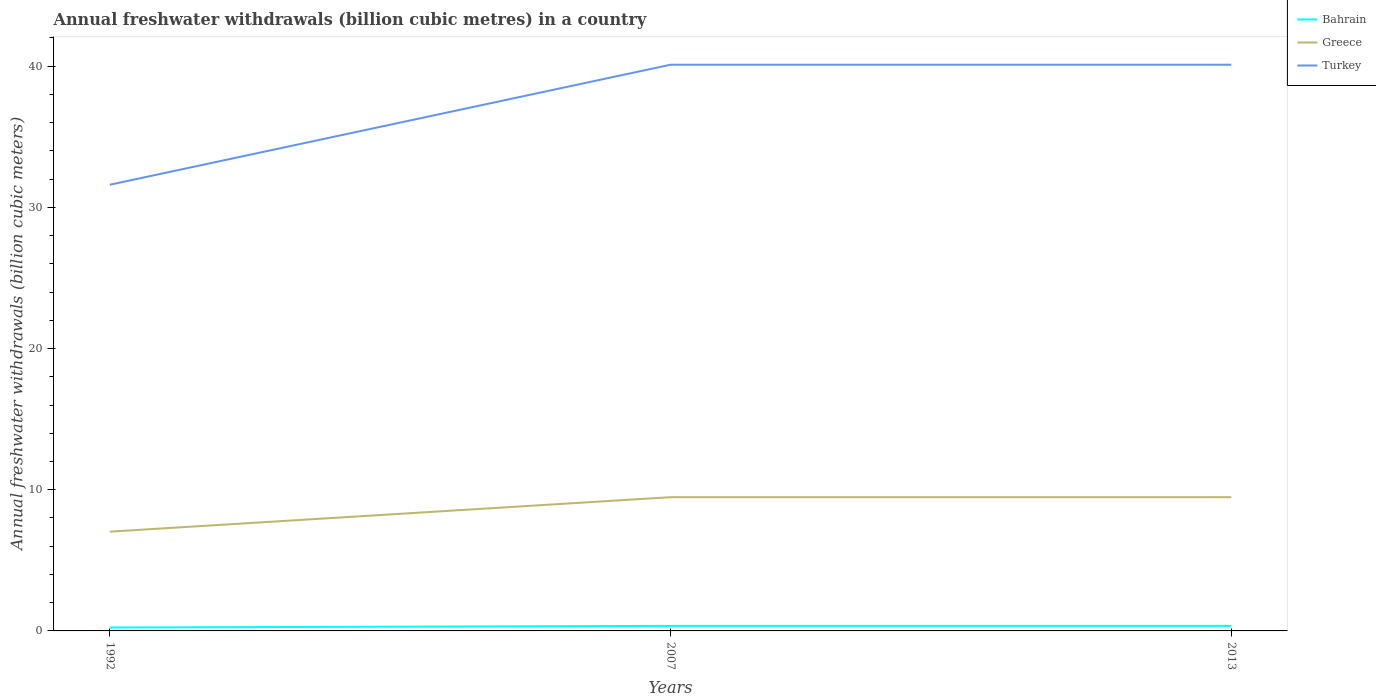Does the line corresponding to Turkey intersect with the line corresponding to Bahrain?
Your response must be concise. No. Across all years, what is the maximum annual freshwater withdrawals in Turkey?
Your answer should be compact. 31.6. In which year was the annual freshwater withdrawals in Turkey maximum?
Give a very brief answer. 1992. What is the total annual freshwater withdrawals in Turkey in the graph?
Offer a very short reply. -8.5. What is the difference between the highest and the second highest annual freshwater withdrawals in Greece?
Keep it short and to the point. 2.44. What is the difference between the highest and the lowest annual freshwater withdrawals in Bahrain?
Provide a succinct answer. 2. Is the annual freshwater withdrawals in Greece strictly greater than the annual freshwater withdrawals in Bahrain over the years?
Your answer should be compact. No. How many years are there in the graph?
Keep it short and to the point. 3. How many legend labels are there?
Offer a very short reply. 3. How are the legend labels stacked?
Provide a succinct answer. Vertical. What is the title of the graph?
Give a very brief answer. Annual freshwater withdrawals (billion cubic metres) in a country. Does "Montenegro" appear as one of the legend labels in the graph?
Keep it short and to the point. No. What is the label or title of the Y-axis?
Provide a succinct answer. Annual freshwater withdrawals (billion cubic meters). What is the Annual freshwater withdrawals (billion cubic meters) of Bahrain in 1992?
Your answer should be compact. 0.24. What is the Annual freshwater withdrawals (billion cubic meters) of Greece in 1992?
Make the answer very short. 7.03. What is the Annual freshwater withdrawals (billion cubic meters) of Turkey in 1992?
Provide a short and direct response. 31.6. What is the Annual freshwater withdrawals (billion cubic meters) in Bahrain in 2007?
Your response must be concise. 0.36. What is the Annual freshwater withdrawals (billion cubic meters) in Greece in 2007?
Keep it short and to the point. 9.47. What is the Annual freshwater withdrawals (billion cubic meters) of Turkey in 2007?
Give a very brief answer. 40.1. What is the Annual freshwater withdrawals (billion cubic meters) in Bahrain in 2013?
Ensure brevity in your answer.  0.36. What is the Annual freshwater withdrawals (billion cubic meters) in Greece in 2013?
Offer a very short reply. 9.47. What is the Annual freshwater withdrawals (billion cubic meters) of Turkey in 2013?
Make the answer very short. 40.1. Across all years, what is the maximum Annual freshwater withdrawals (billion cubic meters) in Bahrain?
Offer a terse response. 0.36. Across all years, what is the maximum Annual freshwater withdrawals (billion cubic meters) of Greece?
Your answer should be compact. 9.47. Across all years, what is the maximum Annual freshwater withdrawals (billion cubic meters) of Turkey?
Give a very brief answer. 40.1. Across all years, what is the minimum Annual freshwater withdrawals (billion cubic meters) in Bahrain?
Offer a very short reply. 0.24. Across all years, what is the minimum Annual freshwater withdrawals (billion cubic meters) of Greece?
Provide a short and direct response. 7.03. Across all years, what is the minimum Annual freshwater withdrawals (billion cubic meters) of Turkey?
Provide a succinct answer. 31.6. What is the total Annual freshwater withdrawals (billion cubic meters) of Bahrain in the graph?
Your answer should be very brief. 0.95. What is the total Annual freshwater withdrawals (billion cubic meters) in Greece in the graph?
Keep it short and to the point. 25.97. What is the total Annual freshwater withdrawals (billion cubic meters) in Turkey in the graph?
Provide a succinct answer. 111.8. What is the difference between the Annual freshwater withdrawals (billion cubic meters) in Bahrain in 1992 and that in 2007?
Provide a short and direct response. -0.12. What is the difference between the Annual freshwater withdrawals (billion cubic meters) in Greece in 1992 and that in 2007?
Your answer should be compact. -2.44. What is the difference between the Annual freshwater withdrawals (billion cubic meters) in Bahrain in 1992 and that in 2013?
Ensure brevity in your answer.  -0.12. What is the difference between the Annual freshwater withdrawals (billion cubic meters) of Greece in 1992 and that in 2013?
Provide a succinct answer. -2.44. What is the difference between the Annual freshwater withdrawals (billion cubic meters) in Bahrain in 1992 and the Annual freshwater withdrawals (billion cubic meters) in Greece in 2007?
Provide a short and direct response. -9.23. What is the difference between the Annual freshwater withdrawals (billion cubic meters) of Bahrain in 1992 and the Annual freshwater withdrawals (billion cubic meters) of Turkey in 2007?
Provide a short and direct response. -39.86. What is the difference between the Annual freshwater withdrawals (billion cubic meters) in Greece in 1992 and the Annual freshwater withdrawals (billion cubic meters) in Turkey in 2007?
Make the answer very short. -33.07. What is the difference between the Annual freshwater withdrawals (billion cubic meters) of Bahrain in 1992 and the Annual freshwater withdrawals (billion cubic meters) of Greece in 2013?
Ensure brevity in your answer.  -9.23. What is the difference between the Annual freshwater withdrawals (billion cubic meters) of Bahrain in 1992 and the Annual freshwater withdrawals (billion cubic meters) of Turkey in 2013?
Offer a very short reply. -39.86. What is the difference between the Annual freshwater withdrawals (billion cubic meters) of Greece in 1992 and the Annual freshwater withdrawals (billion cubic meters) of Turkey in 2013?
Make the answer very short. -33.07. What is the difference between the Annual freshwater withdrawals (billion cubic meters) of Bahrain in 2007 and the Annual freshwater withdrawals (billion cubic meters) of Greece in 2013?
Give a very brief answer. -9.11. What is the difference between the Annual freshwater withdrawals (billion cubic meters) of Bahrain in 2007 and the Annual freshwater withdrawals (billion cubic meters) of Turkey in 2013?
Your answer should be very brief. -39.74. What is the difference between the Annual freshwater withdrawals (billion cubic meters) in Greece in 2007 and the Annual freshwater withdrawals (billion cubic meters) in Turkey in 2013?
Ensure brevity in your answer.  -30.63. What is the average Annual freshwater withdrawals (billion cubic meters) of Bahrain per year?
Provide a short and direct response. 0.32. What is the average Annual freshwater withdrawals (billion cubic meters) of Greece per year?
Provide a succinct answer. 8.66. What is the average Annual freshwater withdrawals (billion cubic meters) in Turkey per year?
Provide a short and direct response. 37.27. In the year 1992, what is the difference between the Annual freshwater withdrawals (billion cubic meters) in Bahrain and Annual freshwater withdrawals (billion cubic meters) in Greece?
Your response must be concise. -6.79. In the year 1992, what is the difference between the Annual freshwater withdrawals (billion cubic meters) in Bahrain and Annual freshwater withdrawals (billion cubic meters) in Turkey?
Give a very brief answer. -31.36. In the year 1992, what is the difference between the Annual freshwater withdrawals (billion cubic meters) of Greece and Annual freshwater withdrawals (billion cubic meters) of Turkey?
Keep it short and to the point. -24.57. In the year 2007, what is the difference between the Annual freshwater withdrawals (billion cubic meters) of Bahrain and Annual freshwater withdrawals (billion cubic meters) of Greece?
Your answer should be very brief. -9.11. In the year 2007, what is the difference between the Annual freshwater withdrawals (billion cubic meters) of Bahrain and Annual freshwater withdrawals (billion cubic meters) of Turkey?
Provide a short and direct response. -39.74. In the year 2007, what is the difference between the Annual freshwater withdrawals (billion cubic meters) in Greece and Annual freshwater withdrawals (billion cubic meters) in Turkey?
Your answer should be compact. -30.63. In the year 2013, what is the difference between the Annual freshwater withdrawals (billion cubic meters) of Bahrain and Annual freshwater withdrawals (billion cubic meters) of Greece?
Your answer should be very brief. -9.11. In the year 2013, what is the difference between the Annual freshwater withdrawals (billion cubic meters) of Bahrain and Annual freshwater withdrawals (billion cubic meters) of Turkey?
Your answer should be compact. -39.74. In the year 2013, what is the difference between the Annual freshwater withdrawals (billion cubic meters) of Greece and Annual freshwater withdrawals (billion cubic meters) of Turkey?
Provide a succinct answer. -30.63. What is the ratio of the Annual freshwater withdrawals (billion cubic meters) in Bahrain in 1992 to that in 2007?
Give a very brief answer. 0.67. What is the ratio of the Annual freshwater withdrawals (billion cubic meters) in Greece in 1992 to that in 2007?
Keep it short and to the point. 0.74. What is the ratio of the Annual freshwater withdrawals (billion cubic meters) of Turkey in 1992 to that in 2007?
Offer a terse response. 0.79. What is the ratio of the Annual freshwater withdrawals (billion cubic meters) in Bahrain in 1992 to that in 2013?
Provide a succinct answer. 0.67. What is the ratio of the Annual freshwater withdrawals (billion cubic meters) in Greece in 1992 to that in 2013?
Keep it short and to the point. 0.74. What is the ratio of the Annual freshwater withdrawals (billion cubic meters) in Turkey in 1992 to that in 2013?
Your response must be concise. 0.79. What is the ratio of the Annual freshwater withdrawals (billion cubic meters) in Turkey in 2007 to that in 2013?
Keep it short and to the point. 1. What is the difference between the highest and the second highest Annual freshwater withdrawals (billion cubic meters) in Bahrain?
Your answer should be very brief. 0. What is the difference between the highest and the second highest Annual freshwater withdrawals (billion cubic meters) of Turkey?
Provide a short and direct response. 0. What is the difference between the highest and the lowest Annual freshwater withdrawals (billion cubic meters) in Bahrain?
Your response must be concise. 0.12. What is the difference between the highest and the lowest Annual freshwater withdrawals (billion cubic meters) of Greece?
Offer a very short reply. 2.44. 